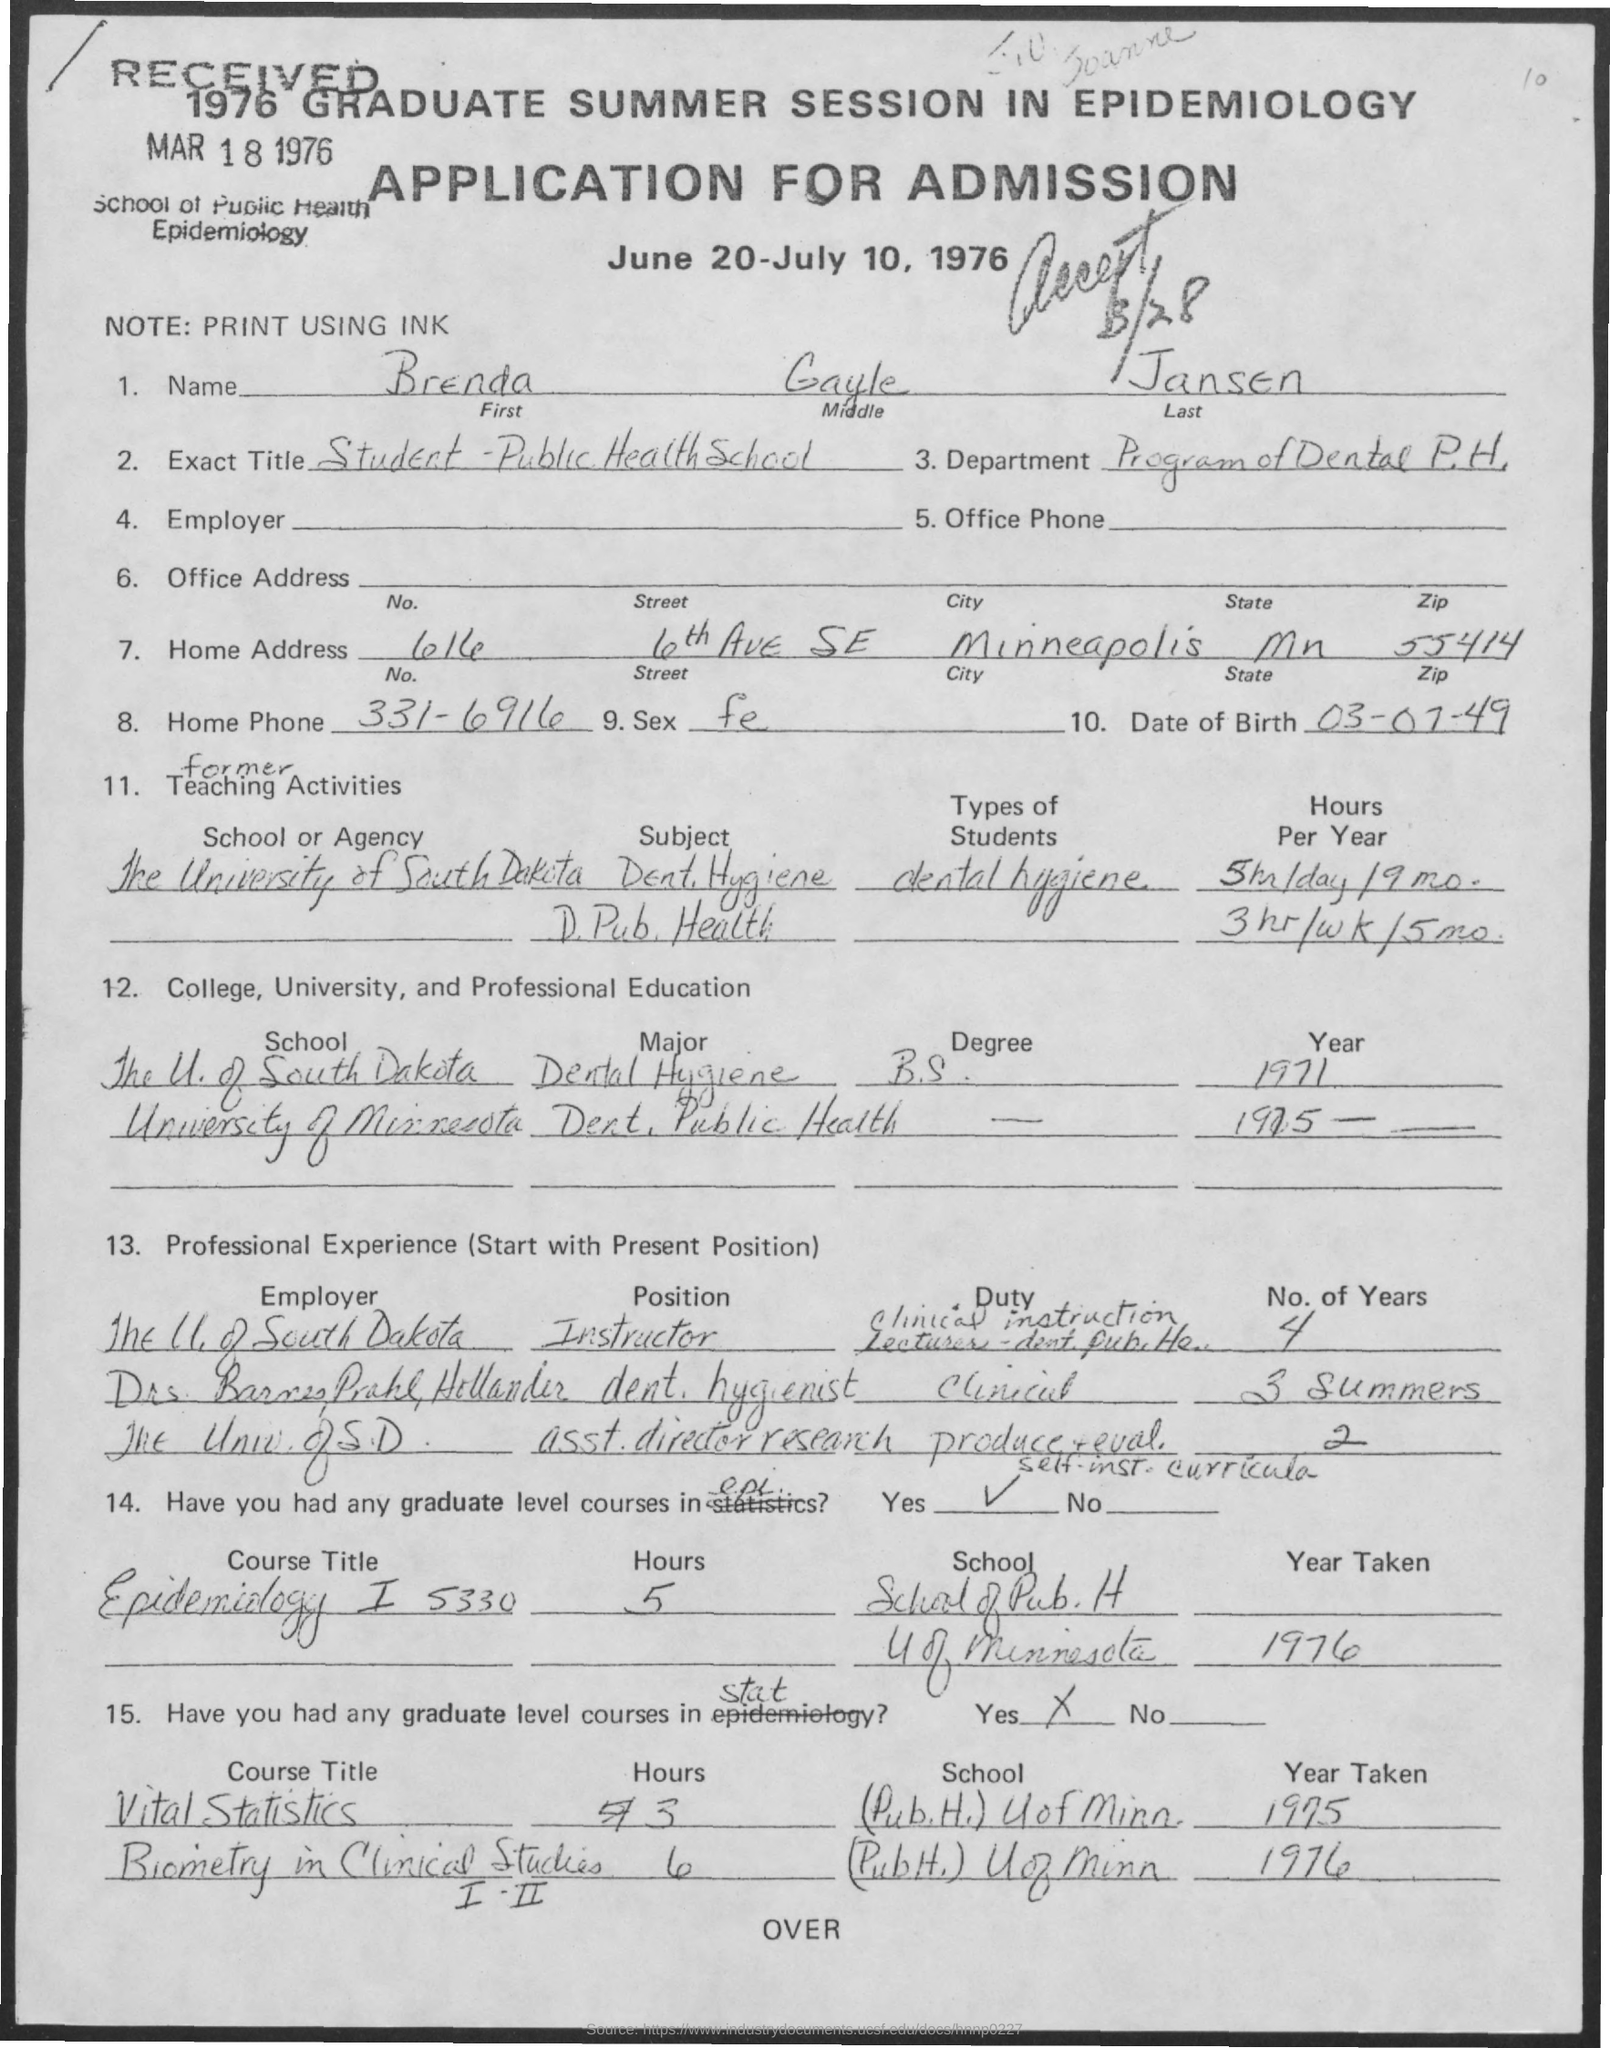What is the First Name?
Offer a very short reply. Brenda. What is the Middle Name?
Ensure brevity in your answer.  Gayle. What is the Last Name?
Your answer should be compact. Jansen. What is the Exact Title?
Make the answer very short. Student - Public Health School. Which is the Department?
Give a very brief answer. Program of Dental P.H. Which is the City?
Offer a very short reply. Minneapolis. Which is the State?
Offer a terse response. Mn. What is the Zip?
Your answer should be very brief. 55414. What is the Date Of Birth?
Your answer should be very brief. 03-07-49. 